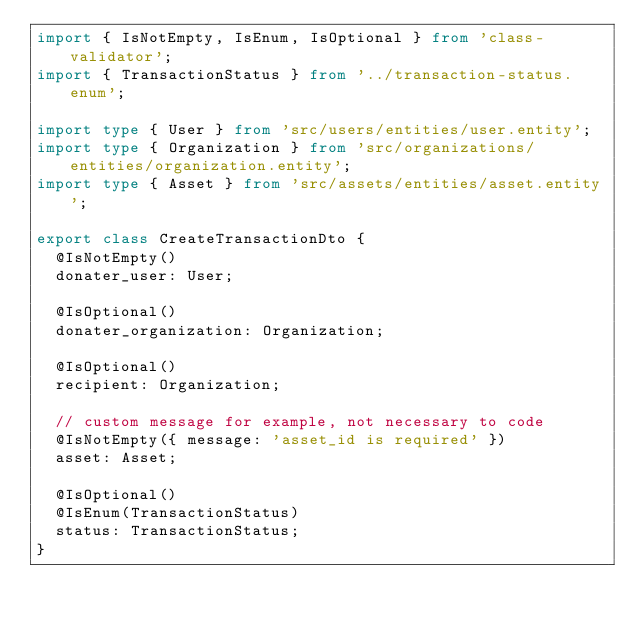Convert code to text. <code><loc_0><loc_0><loc_500><loc_500><_TypeScript_>import { IsNotEmpty, IsEnum, IsOptional } from 'class-validator';
import { TransactionStatus } from '../transaction-status.enum';

import type { User } from 'src/users/entities/user.entity';
import type { Organization } from 'src/organizations/entities/organization.entity';
import type { Asset } from 'src/assets/entities/asset.entity';

export class CreateTransactionDto {
  @IsNotEmpty()
  donater_user: User;

  @IsOptional()
  donater_organization: Organization;

  @IsOptional()
  recipient: Organization;

  // custom message for example, not necessary to code
  @IsNotEmpty({ message: 'asset_id is required' })
  asset: Asset;

  @IsOptional()
  @IsEnum(TransactionStatus)
  status: TransactionStatus;
}
</code> 